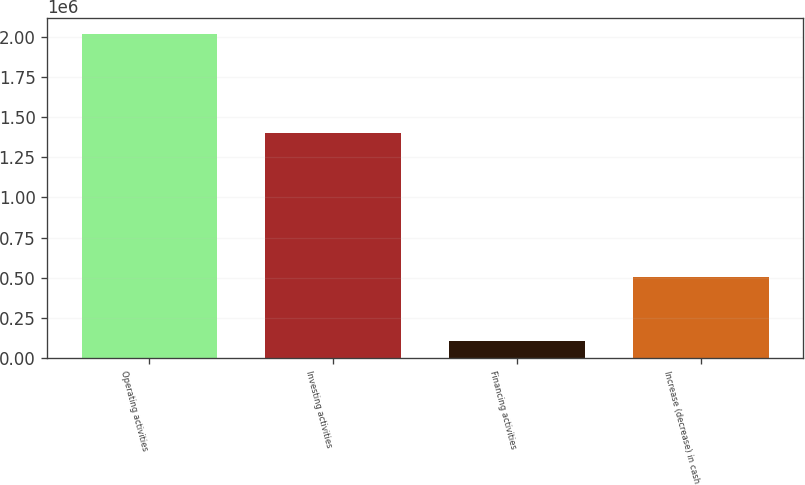Convert chart to OTSL. <chart><loc_0><loc_0><loc_500><loc_500><bar_chart><fcel>Operating activities<fcel>Investing activities<fcel>Financing activities<fcel>Increase (decrease) in cash<nl><fcel>2.01657e+06<fcel>1.40309e+06<fcel>107029<fcel>506455<nl></chart> 